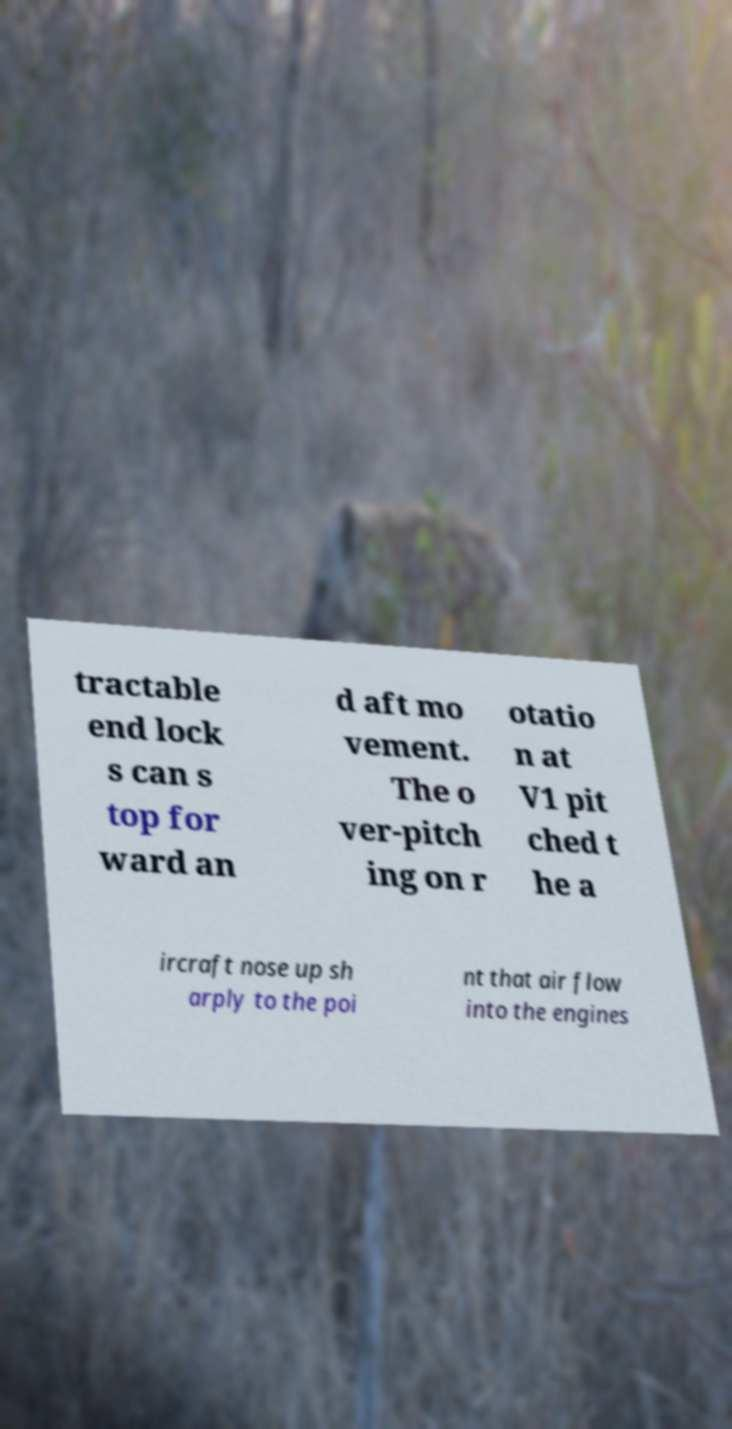Could you extract and type out the text from this image? tractable end lock s can s top for ward an d aft mo vement. The o ver-pitch ing on r otatio n at V1 pit ched t he a ircraft nose up sh arply to the poi nt that air flow into the engines 